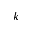Convert formula to latex. <formula><loc_0><loc_0><loc_500><loc_500>k</formula> 